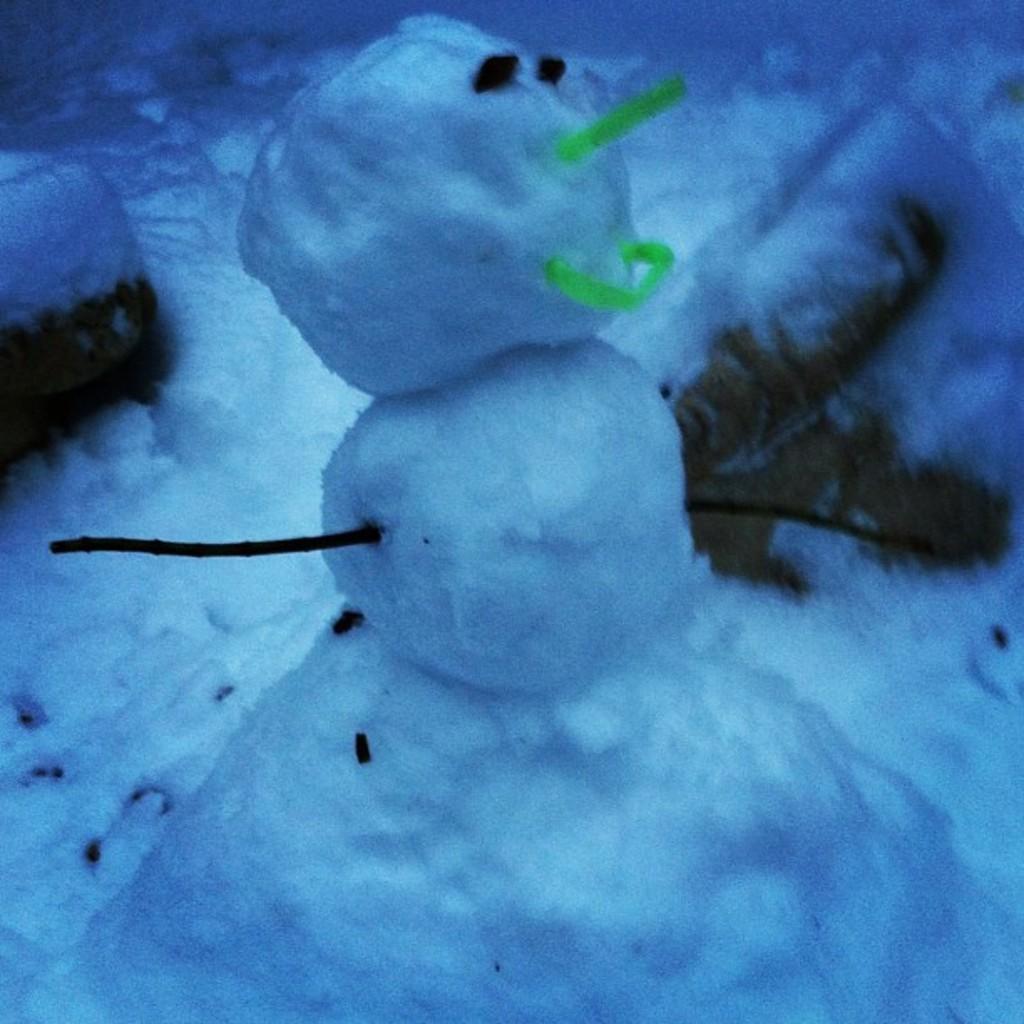How would you summarize this image in a sentence or two? In this image I see the white snow and I see a snowman over here. 